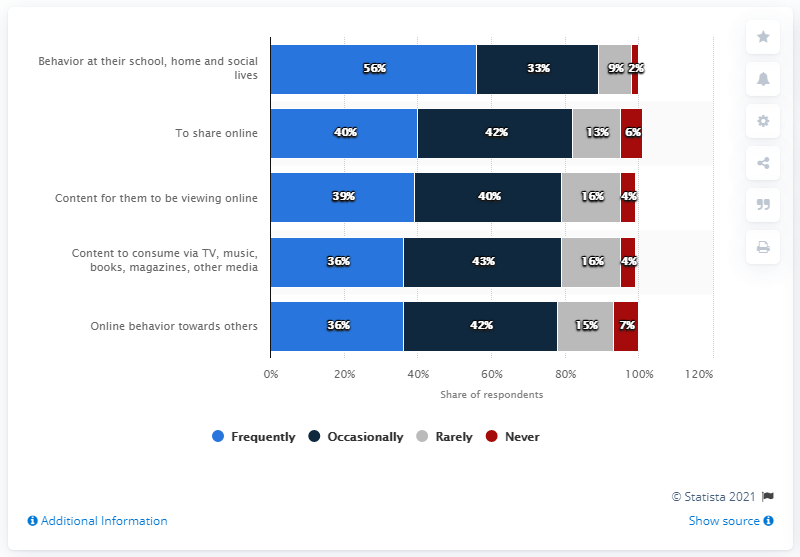Draw attention to some important aspects in this diagram. The average frequency of never discussing the five acceptable digital behaviors is 4.6. 